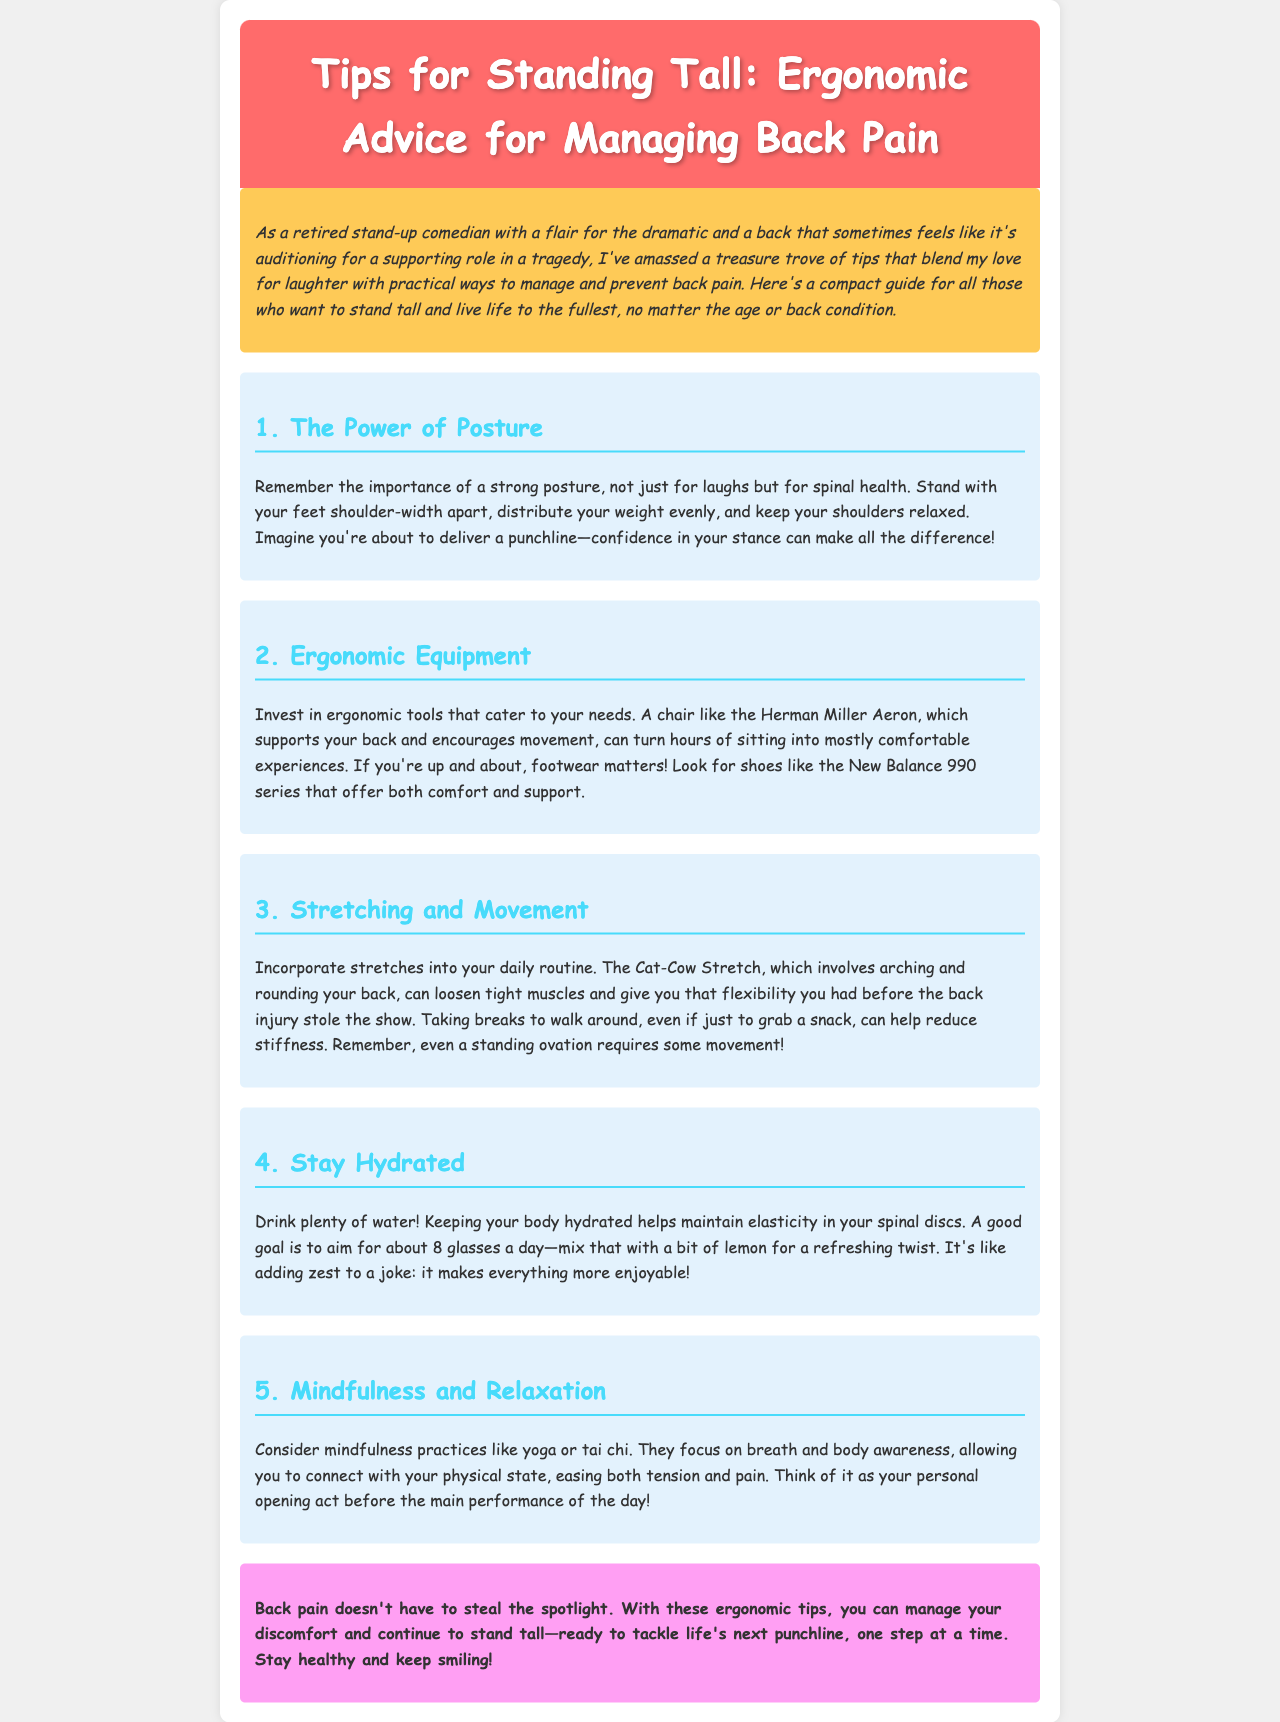What is the main theme of the document? The document provides tips for managing and preventing back pain through ergonomic advice.
Answer: ergonomic advice for managing back pain What is one example of ergonomic equipment mentioned? The document lists the Herman Miller Aeron as a supportive ergonomic chair.
Answer: Herman Miller Aeron How many glasses of water should one aim to drink daily? The document states a goal of about 8 glasses of water a day.
Answer: 8 glasses What type of stretch is recommended for loosening muscles? The Cat-Cow Stretch is suggested for loosening tight muscles.
Answer: Cat-Cow Stretch Which mindfulness practice is suggested in the document? The document recommends practices like yoga or tai chi for mindfulness.
Answer: yoga or tai chi What should one imagine to maintain proper posture? The document advises to imagine delivering a punchline to maintain confidence in stance.
Answer: delivering a punchline What is the color of the section headers? Section headers are colored in #48dbfb in the document.
Answer: #48dbfb What is the purpose of the introduction section? The introduction provides a personal touch and contextualizes the tips with humor.
Answer: personal touch and humor What is the effect of staying hydrated on spinal discs? Staying hydrated helps maintain elasticity in spinal discs.
Answer: elasticity in spinal discs 